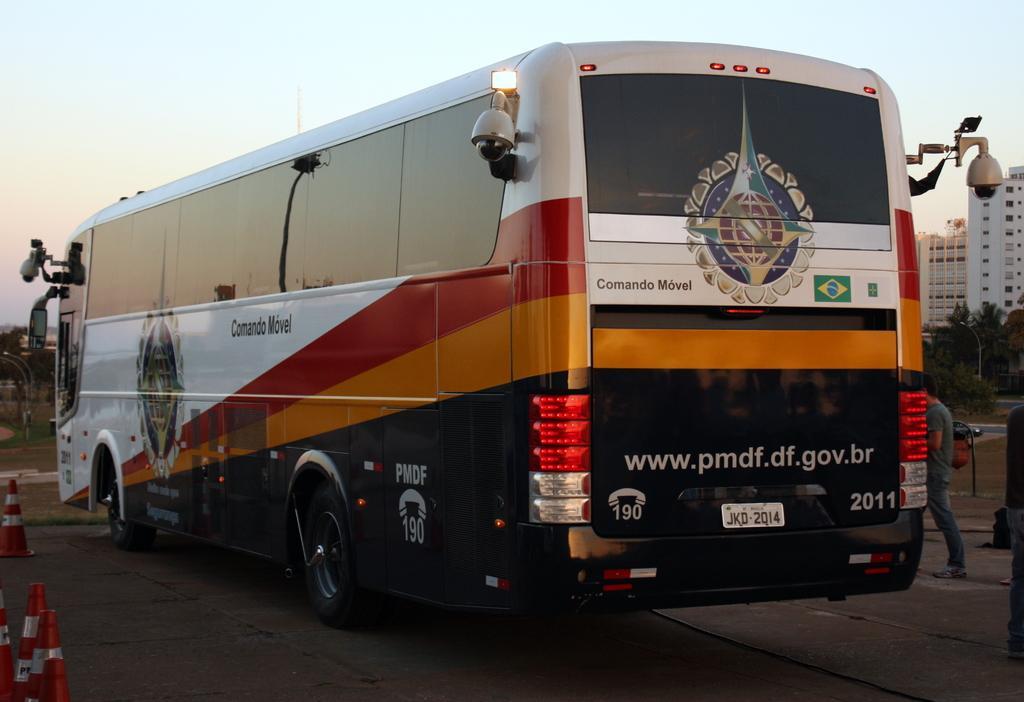In one or two sentences, can you explain what this image depicts? In this image, I can see a bus on the road. At the bottom left side of the image, I can see the cone barriers. On the right side of the image, there are buildings, trees and a person standing. In the background, there is the sky. 